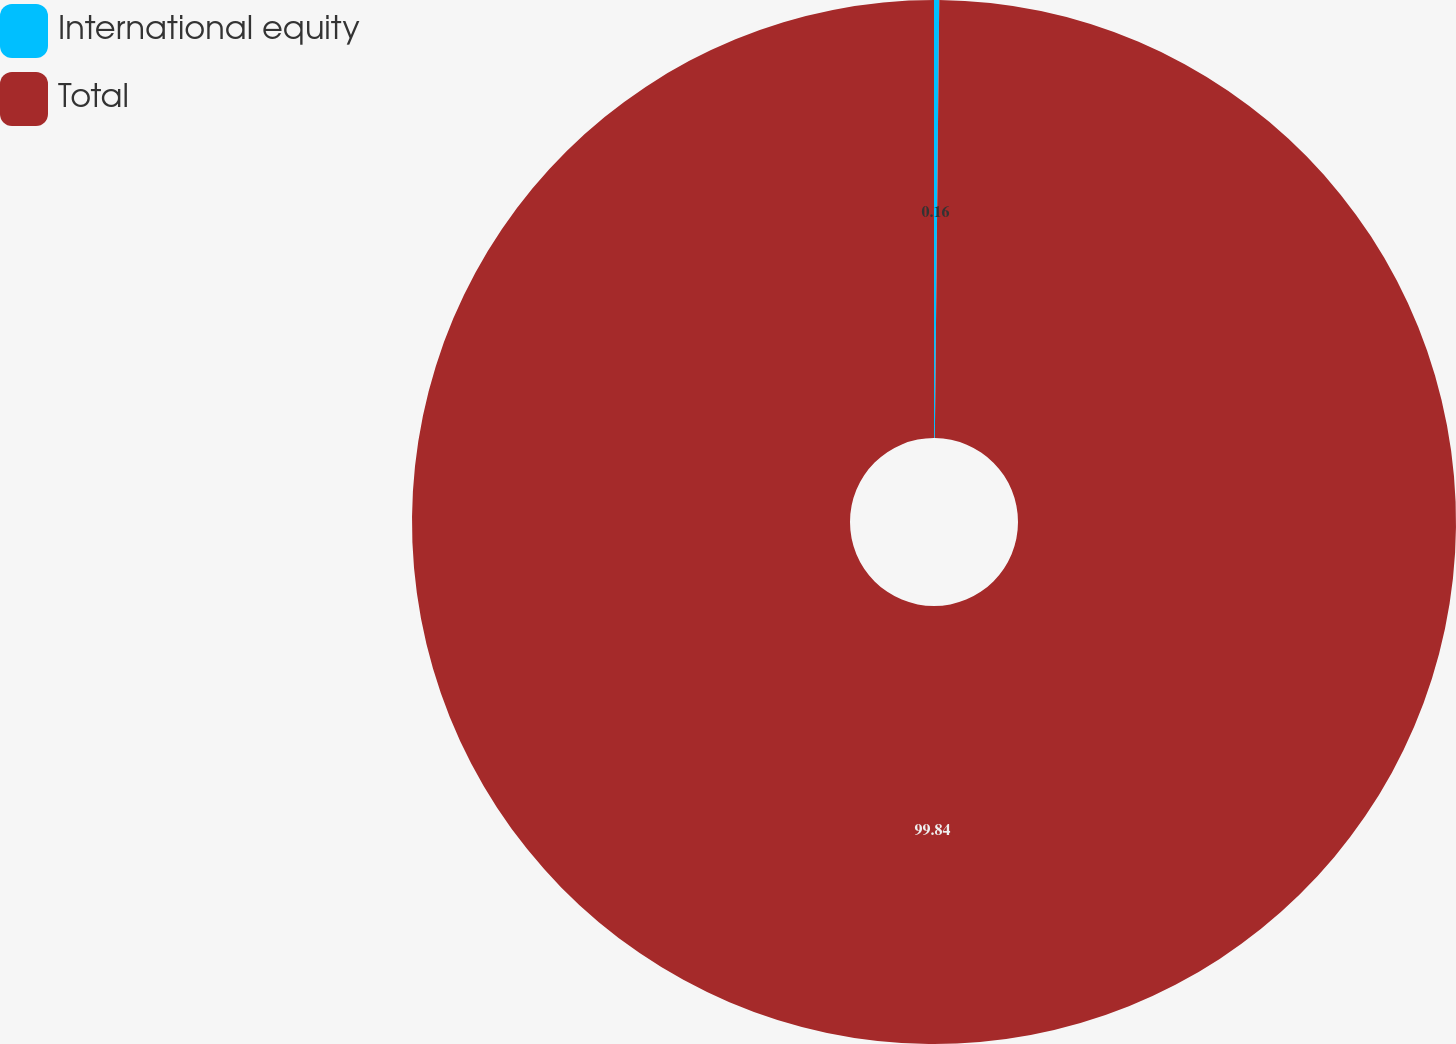Convert chart to OTSL. <chart><loc_0><loc_0><loc_500><loc_500><pie_chart><fcel>International equity<fcel>Total<nl><fcel>0.16%<fcel>99.84%<nl></chart> 